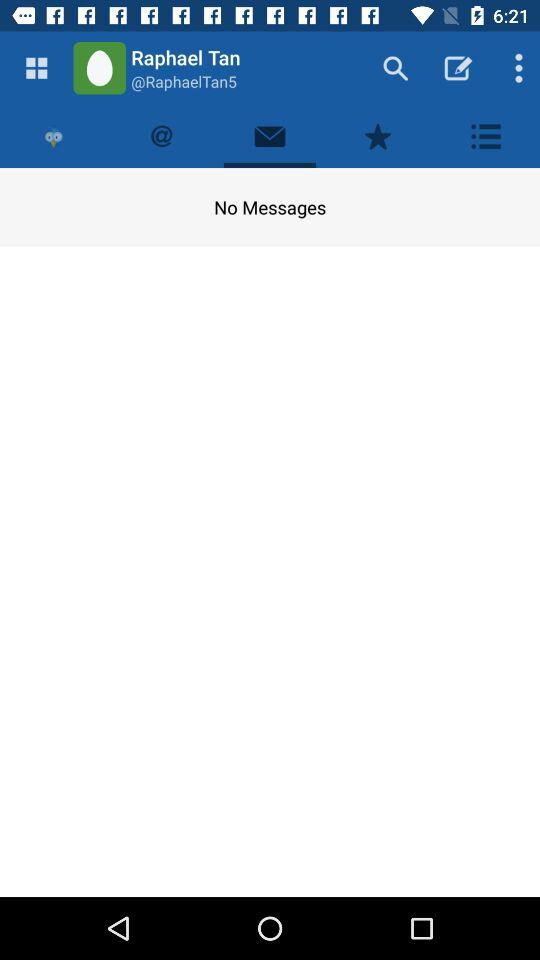How many messages are there? There are no messages. 